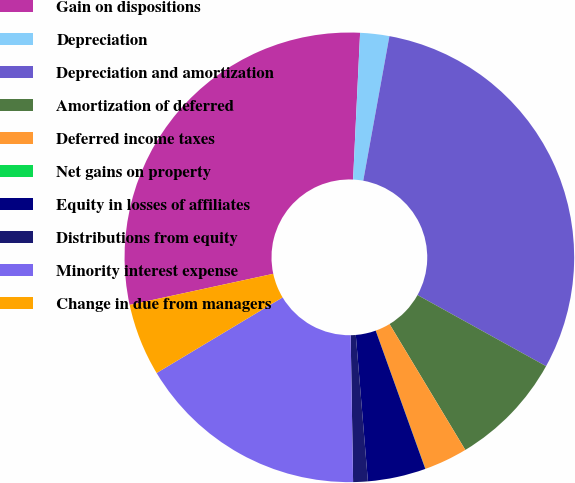<chart> <loc_0><loc_0><loc_500><loc_500><pie_chart><fcel>Gain on dispositions<fcel>Depreciation<fcel>Depreciation and amortization<fcel>Amortization of deferred<fcel>Deferred income taxes<fcel>Net gains on property<fcel>Equity in losses of affiliates<fcel>Distributions from equity<fcel>Minority interest expense<fcel>Change in due from managers<nl><fcel>29.15%<fcel>2.09%<fcel>30.19%<fcel>8.33%<fcel>3.13%<fcel>0.01%<fcel>4.17%<fcel>1.05%<fcel>16.66%<fcel>5.21%<nl></chart> 